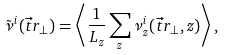Convert formula to latex. <formula><loc_0><loc_0><loc_500><loc_500>\tilde { \nu } ^ { i } ( \vec { t } { r } _ { \perp } ) = \left < \frac { 1 } { L _ { z } } \sum _ { z } \nu _ { z } ^ { i } ( \vec { t } { r } _ { \perp } , z ) \right > ,</formula> 